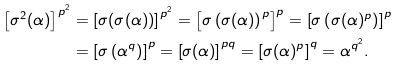Convert formula to latex. <formula><loc_0><loc_0><loc_500><loc_500>\left [ \sigma ^ { 2 } ( \alpha ) \right ] ^ { p ^ { 2 } } & = \left [ \sigma ( \sigma ( \alpha ) ) \right ] ^ { p ^ { 2 } } = \left [ \sigma \left ( \sigma ( \alpha ) \right ) ^ { p } \right ] ^ { p } = \left [ \sigma \left ( \sigma ( \alpha ) ^ { p } \right ) \right ] ^ { p } \\ & = \left [ \sigma \left ( \alpha ^ { q } \right ) \right ] ^ { p } = \left [ \sigma ( \alpha ) \right ] ^ { p q } = \left [ \sigma ( \alpha ) ^ { p } \right ] ^ { q } = \alpha ^ { q ^ { 2 } } .</formula> 